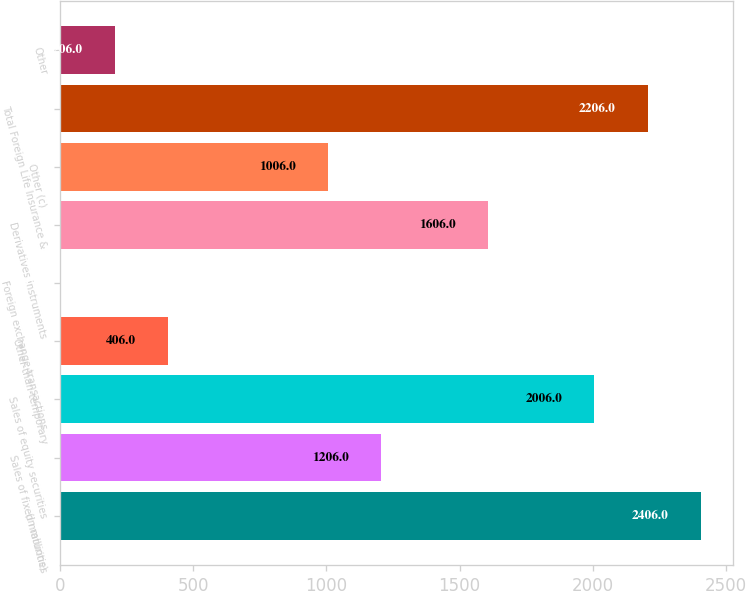Convert chart. <chart><loc_0><loc_0><loc_500><loc_500><bar_chart><fcel>(in millions)<fcel>Sales of fixed maturities<fcel>Sales of equity securities<fcel>Other-than-temporary<fcel>Foreign exchange transactions<fcel>Derivatives instruments<fcel>Other (c)<fcel>Total Foreign Life Insurance &<fcel>Other<nl><fcel>2406<fcel>1206<fcel>2006<fcel>406<fcel>6<fcel>1606<fcel>1006<fcel>2206<fcel>206<nl></chart> 